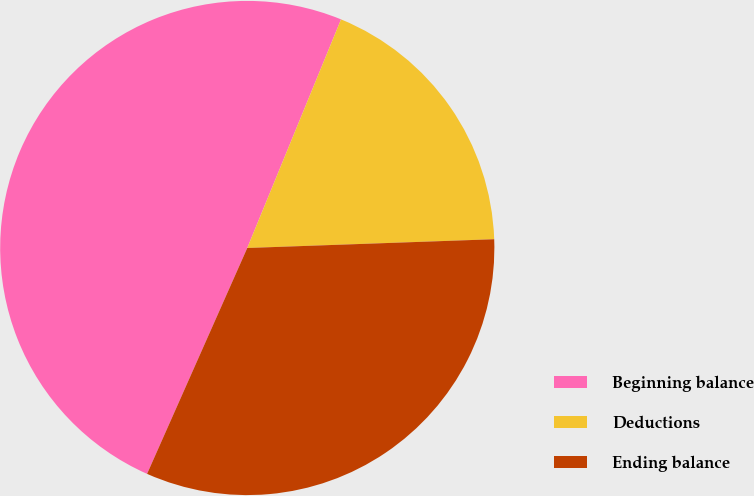Convert chart to OTSL. <chart><loc_0><loc_0><loc_500><loc_500><pie_chart><fcel>Beginning balance<fcel>Deductions<fcel>Ending balance<nl><fcel>49.55%<fcel>18.24%<fcel>32.21%<nl></chart> 